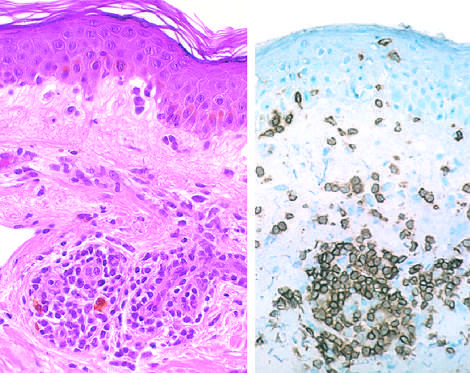does immunoperoxidase staining reveal a predominantly perivascular cellular infiltrate that marks positively with anti-cd4 antibodies?
Answer the question using a single word or phrase. Yes 